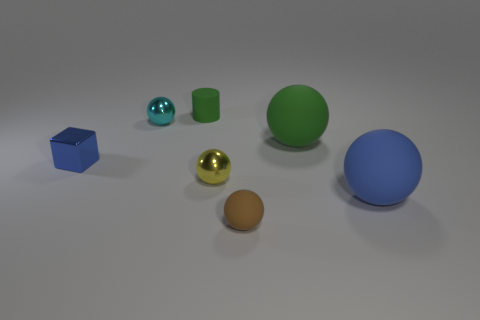Subtract all green matte spheres. How many spheres are left? 4 Subtract 2 balls. How many balls are left? 3 Add 3 tiny purple cylinders. How many objects exist? 10 Subtract all cyan spheres. How many spheres are left? 4 Subtract all cubes. How many objects are left? 6 Subtract all gray spheres. Subtract all cyan cylinders. How many spheres are left? 5 Add 4 tiny cyan shiny balls. How many tiny cyan shiny balls exist? 5 Subtract 1 green cylinders. How many objects are left? 6 Subtract all cyan balls. Subtract all cyan things. How many objects are left? 5 Add 1 tiny green objects. How many tiny green objects are left? 2 